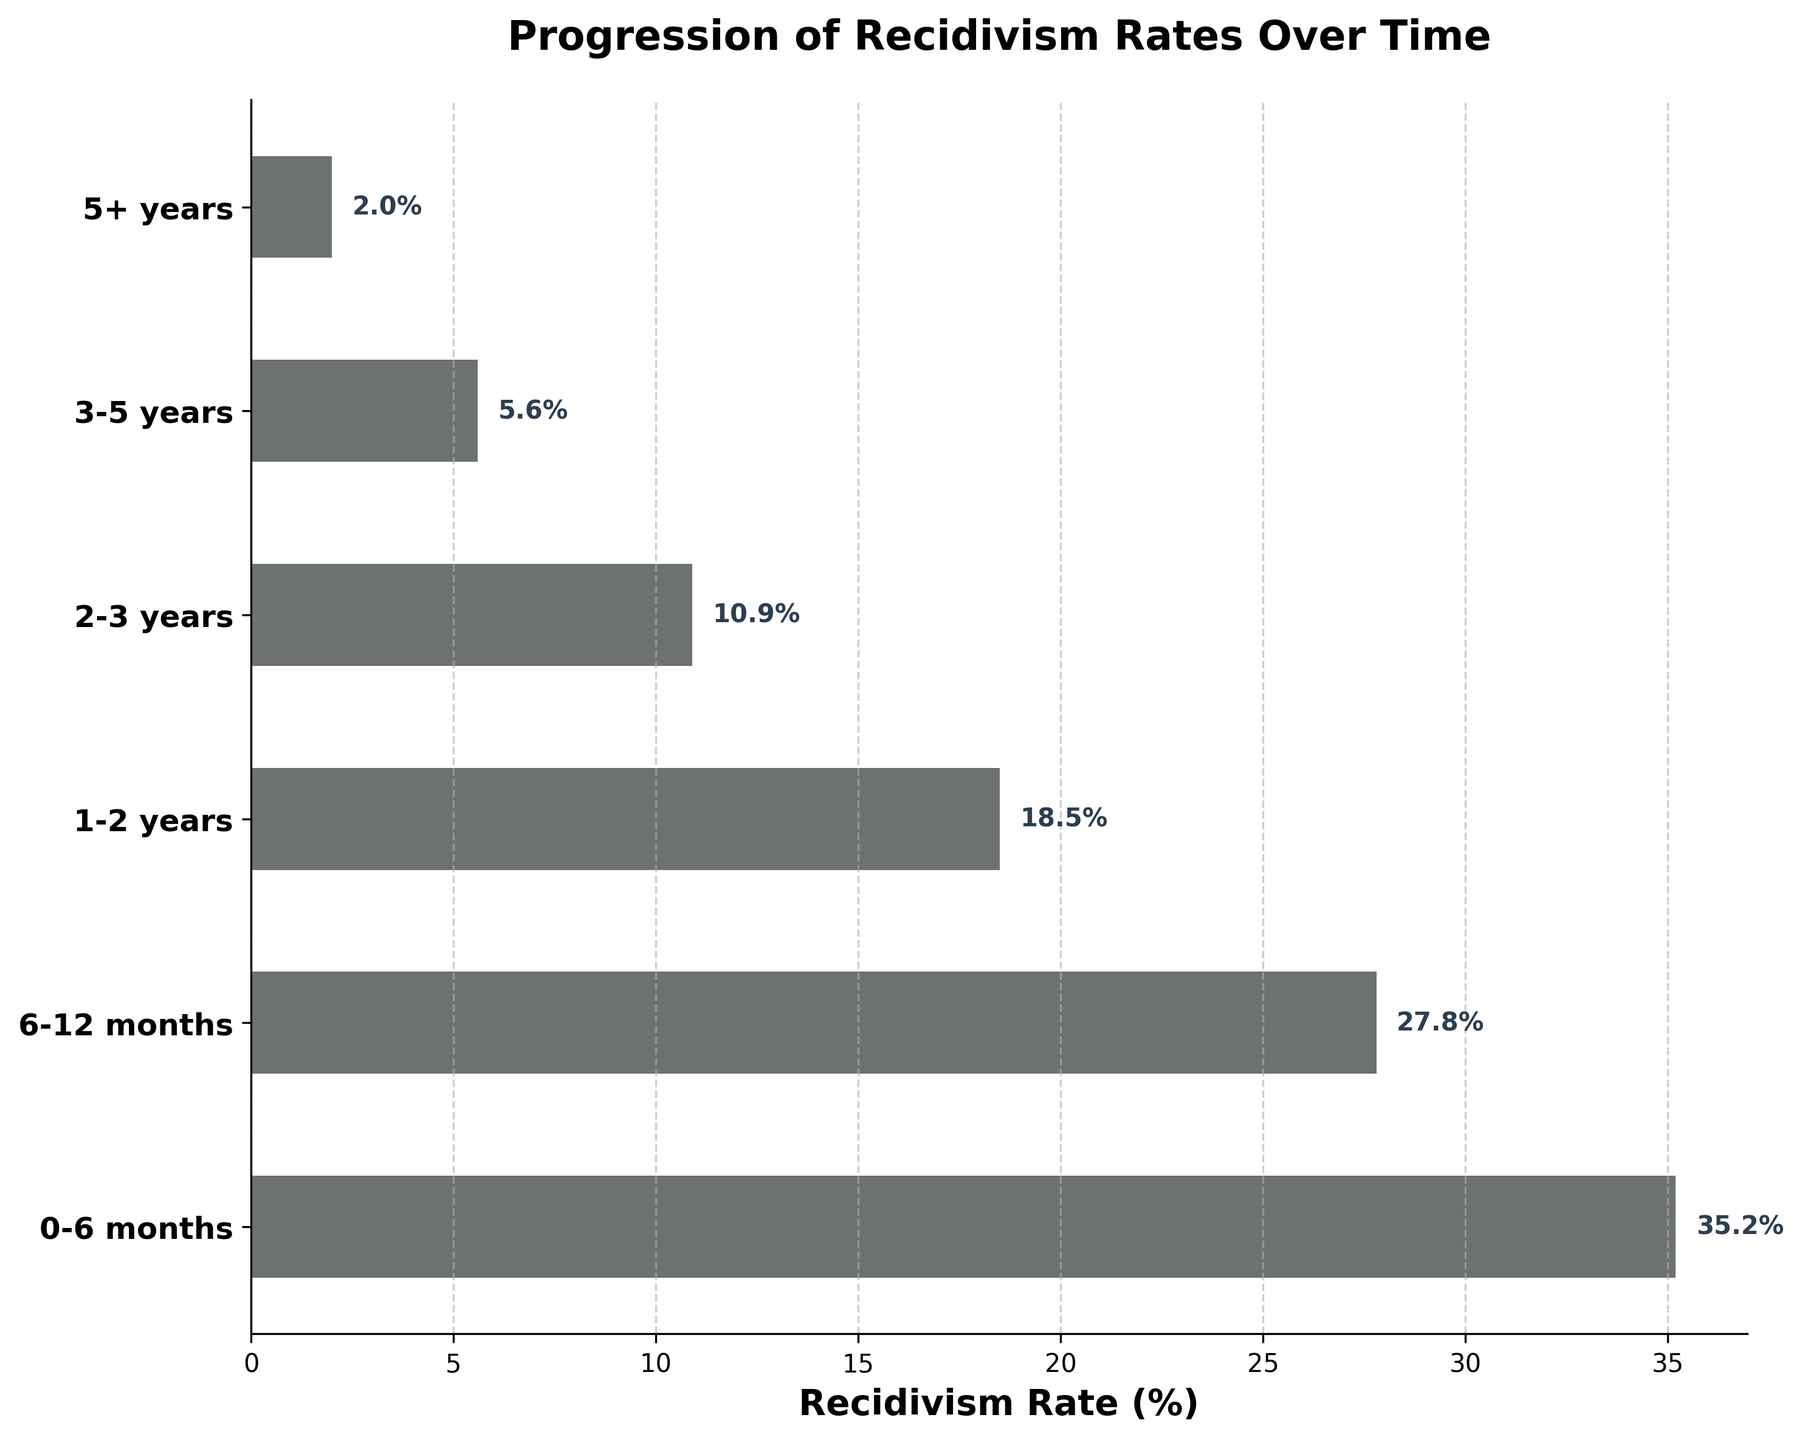What is the title of the figure? The title is found at the top of the figure in bold font.
Answer: Progression of Recidivism Rates Over Time Which category has the highest recidivism rate? By looking at the left-hand side labels and the corresponding horizontal bar lengths, the category with the longest bar represents the highest rate.
Answer: 0-6 months How does the recidivism rate change as time progresses from 0-6 months to 5+ years? The lengths of the horizontal bars decrease from 0-6 months to 5+ years, indicating a downward trend in recidivism rates over time.
Answer: It decreases What is the recidivism rate for the 1-2 years category? Locate the bar corresponding to the 1-2 years category on the y-axis and read off the number at the end of the bar.
Answer: 18.5% What is the difference in recidivism rates between 0-6 months and 5+ years? Find the values of both 0-6 months and 5+ years categories and subtract the latter from the former (35.2 - 2.0).
Answer: 33.2% Which two consecutive time categories show the largest drop in recidivism rates? Compare the difference in values between each pair of consecutive categories. The pair with the largest difference is the answer. (35.2 - 27.8 = 7.4, 27.8 - 18.5 = 9.3, etc.)
Answer: 6-12 months to 1-2 years How does the recidivism rate of 6-12 months compare to that of 2-3 years? By comparing the lengths of horizontal bars for 6-12 months and 2-3 years, the bar for 6-12 months is longer.
Answer: 6-12 months is higher What proportion of the recidivism rate for 0-6 months is the rate for 3-5 years? Use the values for both categories and divide the 3-5 years rate by the 0-6 months rate (5.6 / 35.2). Multiply by 100 if you need the percentage.
Answer: 15.9% If the recidivism rate trend continues, what would you expect to happen to the rate after 5+ years? Extrapolate the decreasing trend in the bars' length forward; since the sequence shows a continued decline, we'd expect it to decrease further.
Answer: It would continue to decrease 